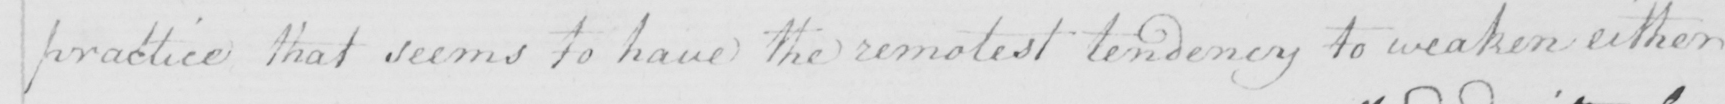Can you read and transcribe this handwriting? practice that seems to have the remotest tendency to weaken either 